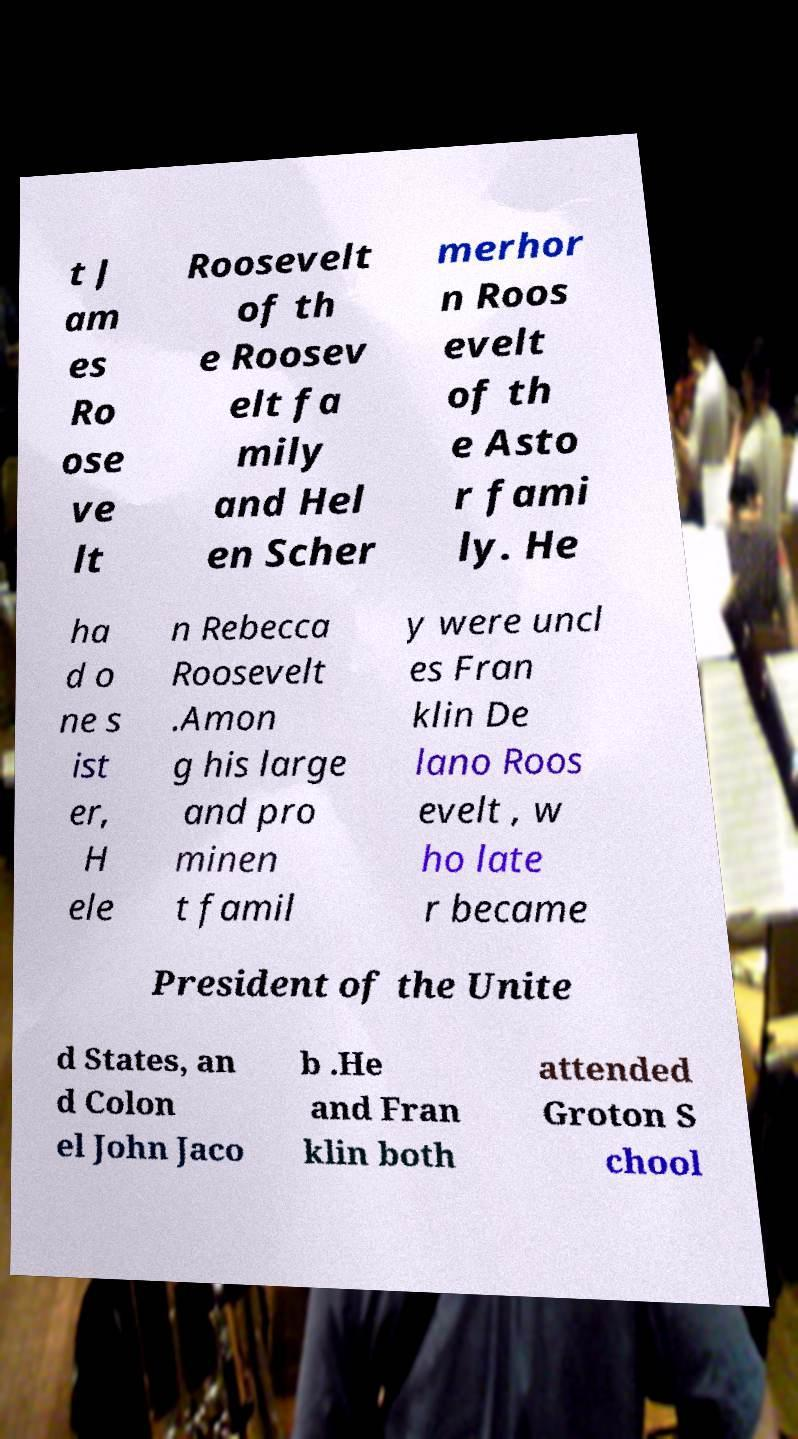What messages or text are displayed in this image? I need them in a readable, typed format. t J am es Ro ose ve lt Roosevelt of th e Roosev elt fa mily and Hel en Scher merhor n Roos evelt of th e Asto r fami ly. He ha d o ne s ist er, H ele n Rebecca Roosevelt .Amon g his large and pro minen t famil y were uncl es Fran klin De lano Roos evelt , w ho late r became President of the Unite d States, an d Colon el John Jaco b .He and Fran klin both attended Groton S chool 